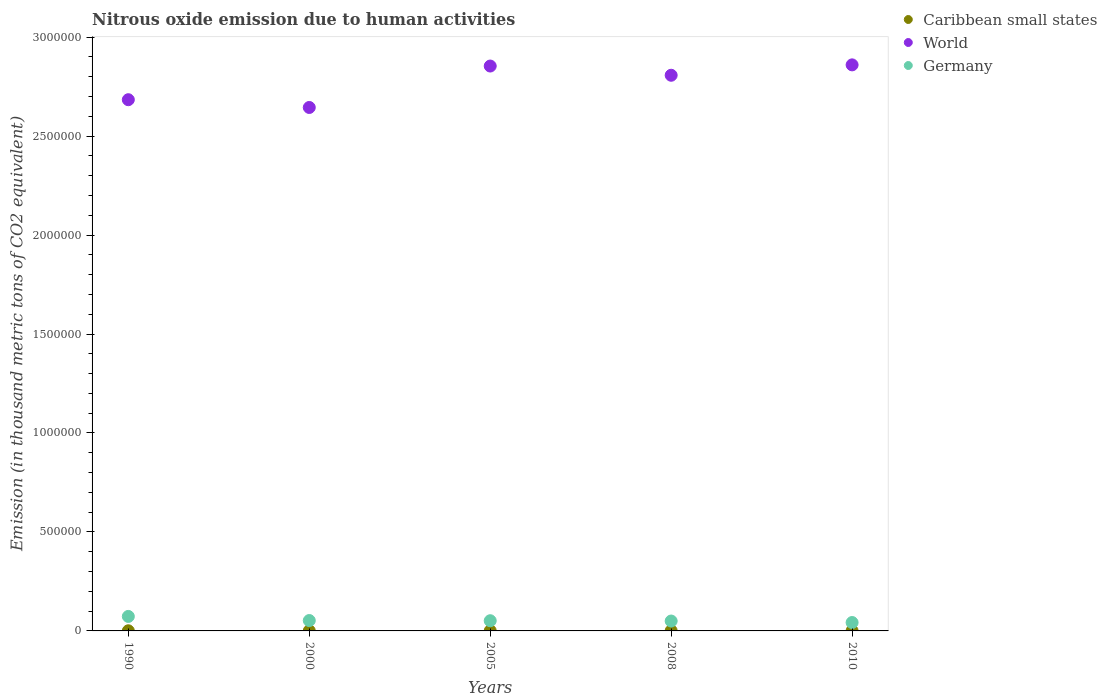What is the amount of nitrous oxide emitted in Caribbean small states in 2008?
Your answer should be compact. 1003.4. Across all years, what is the maximum amount of nitrous oxide emitted in Caribbean small states?
Keep it short and to the point. 1003.4. Across all years, what is the minimum amount of nitrous oxide emitted in Germany?
Make the answer very short. 4.24e+04. In which year was the amount of nitrous oxide emitted in Germany maximum?
Offer a terse response. 1990. In which year was the amount of nitrous oxide emitted in Caribbean small states minimum?
Offer a very short reply. 1990. What is the total amount of nitrous oxide emitted in Germany in the graph?
Make the answer very short. 2.70e+05. What is the difference between the amount of nitrous oxide emitted in Caribbean small states in 2008 and that in 2010?
Provide a short and direct response. 84.3. What is the difference between the amount of nitrous oxide emitted in Caribbean small states in 1990 and the amount of nitrous oxide emitted in World in 2005?
Provide a succinct answer. -2.85e+06. What is the average amount of nitrous oxide emitted in Caribbean small states per year?
Offer a very short reply. 882.52. In the year 2010, what is the difference between the amount of nitrous oxide emitted in Germany and amount of nitrous oxide emitted in Caribbean small states?
Ensure brevity in your answer.  4.15e+04. In how many years, is the amount of nitrous oxide emitted in World greater than 500000 thousand metric tons?
Your response must be concise. 5. What is the ratio of the amount of nitrous oxide emitted in Caribbean small states in 1990 to that in 2008?
Your answer should be very brief. 0.7. Is the difference between the amount of nitrous oxide emitted in Germany in 2008 and 2010 greater than the difference between the amount of nitrous oxide emitted in Caribbean small states in 2008 and 2010?
Offer a terse response. Yes. What is the difference between the highest and the second highest amount of nitrous oxide emitted in Germany?
Give a very brief answer. 2.07e+04. What is the difference between the highest and the lowest amount of nitrous oxide emitted in World?
Your response must be concise. 2.15e+05. Is it the case that in every year, the sum of the amount of nitrous oxide emitted in Caribbean small states and amount of nitrous oxide emitted in World  is greater than the amount of nitrous oxide emitted in Germany?
Keep it short and to the point. Yes. Does the amount of nitrous oxide emitted in World monotonically increase over the years?
Provide a short and direct response. No. Is the amount of nitrous oxide emitted in World strictly greater than the amount of nitrous oxide emitted in Caribbean small states over the years?
Make the answer very short. Yes. Is the amount of nitrous oxide emitted in World strictly less than the amount of nitrous oxide emitted in Caribbean small states over the years?
Offer a terse response. No. How many years are there in the graph?
Your answer should be compact. 5. What is the difference between two consecutive major ticks on the Y-axis?
Provide a succinct answer. 5.00e+05. Does the graph contain any zero values?
Provide a short and direct response. No. Where does the legend appear in the graph?
Offer a terse response. Top right. What is the title of the graph?
Provide a succinct answer. Nitrous oxide emission due to human activities. What is the label or title of the Y-axis?
Provide a short and direct response. Emission (in thousand metric tons of CO2 equivalent). What is the Emission (in thousand metric tons of CO2 equivalent) in Caribbean small states in 1990?
Give a very brief answer. 699.1. What is the Emission (in thousand metric tons of CO2 equivalent) in World in 1990?
Provide a succinct answer. 2.68e+06. What is the Emission (in thousand metric tons of CO2 equivalent) in Germany in 1990?
Your answer should be very brief. 7.32e+04. What is the Emission (in thousand metric tons of CO2 equivalent) of Caribbean small states in 2000?
Make the answer very short. 867.7. What is the Emission (in thousand metric tons of CO2 equivalent) in World in 2000?
Provide a succinct answer. 2.64e+06. What is the Emission (in thousand metric tons of CO2 equivalent) in Germany in 2000?
Your response must be concise. 5.25e+04. What is the Emission (in thousand metric tons of CO2 equivalent) in Caribbean small states in 2005?
Make the answer very short. 923.3. What is the Emission (in thousand metric tons of CO2 equivalent) of World in 2005?
Your answer should be very brief. 2.85e+06. What is the Emission (in thousand metric tons of CO2 equivalent) in Germany in 2005?
Provide a succinct answer. 5.15e+04. What is the Emission (in thousand metric tons of CO2 equivalent) of Caribbean small states in 2008?
Your answer should be compact. 1003.4. What is the Emission (in thousand metric tons of CO2 equivalent) in World in 2008?
Make the answer very short. 2.81e+06. What is the Emission (in thousand metric tons of CO2 equivalent) of Germany in 2008?
Ensure brevity in your answer.  5.00e+04. What is the Emission (in thousand metric tons of CO2 equivalent) of Caribbean small states in 2010?
Provide a short and direct response. 919.1. What is the Emission (in thousand metric tons of CO2 equivalent) in World in 2010?
Your answer should be very brief. 2.86e+06. What is the Emission (in thousand metric tons of CO2 equivalent) in Germany in 2010?
Give a very brief answer. 4.24e+04. Across all years, what is the maximum Emission (in thousand metric tons of CO2 equivalent) in Caribbean small states?
Your answer should be very brief. 1003.4. Across all years, what is the maximum Emission (in thousand metric tons of CO2 equivalent) of World?
Offer a very short reply. 2.86e+06. Across all years, what is the maximum Emission (in thousand metric tons of CO2 equivalent) in Germany?
Offer a very short reply. 7.32e+04. Across all years, what is the minimum Emission (in thousand metric tons of CO2 equivalent) in Caribbean small states?
Your answer should be compact. 699.1. Across all years, what is the minimum Emission (in thousand metric tons of CO2 equivalent) of World?
Give a very brief answer. 2.64e+06. Across all years, what is the minimum Emission (in thousand metric tons of CO2 equivalent) in Germany?
Your answer should be very brief. 4.24e+04. What is the total Emission (in thousand metric tons of CO2 equivalent) of Caribbean small states in the graph?
Provide a succinct answer. 4412.6. What is the total Emission (in thousand metric tons of CO2 equivalent) in World in the graph?
Your answer should be compact. 1.38e+07. What is the total Emission (in thousand metric tons of CO2 equivalent) in Germany in the graph?
Offer a terse response. 2.70e+05. What is the difference between the Emission (in thousand metric tons of CO2 equivalent) in Caribbean small states in 1990 and that in 2000?
Give a very brief answer. -168.6. What is the difference between the Emission (in thousand metric tons of CO2 equivalent) of World in 1990 and that in 2000?
Your response must be concise. 3.92e+04. What is the difference between the Emission (in thousand metric tons of CO2 equivalent) of Germany in 1990 and that in 2000?
Your response must be concise. 2.07e+04. What is the difference between the Emission (in thousand metric tons of CO2 equivalent) in Caribbean small states in 1990 and that in 2005?
Provide a short and direct response. -224.2. What is the difference between the Emission (in thousand metric tons of CO2 equivalent) of World in 1990 and that in 2005?
Your answer should be compact. -1.70e+05. What is the difference between the Emission (in thousand metric tons of CO2 equivalent) of Germany in 1990 and that in 2005?
Ensure brevity in your answer.  2.17e+04. What is the difference between the Emission (in thousand metric tons of CO2 equivalent) in Caribbean small states in 1990 and that in 2008?
Provide a succinct answer. -304.3. What is the difference between the Emission (in thousand metric tons of CO2 equivalent) in World in 1990 and that in 2008?
Provide a succinct answer. -1.24e+05. What is the difference between the Emission (in thousand metric tons of CO2 equivalent) of Germany in 1990 and that in 2008?
Ensure brevity in your answer.  2.32e+04. What is the difference between the Emission (in thousand metric tons of CO2 equivalent) of Caribbean small states in 1990 and that in 2010?
Provide a succinct answer. -220. What is the difference between the Emission (in thousand metric tons of CO2 equivalent) of World in 1990 and that in 2010?
Provide a succinct answer. -1.76e+05. What is the difference between the Emission (in thousand metric tons of CO2 equivalent) of Germany in 1990 and that in 2010?
Offer a terse response. 3.08e+04. What is the difference between the Emission (in thousand metric tons of CO2 equivalent) of Caribbean small states in 2000 and that in 2005?
Provide a succinct answer. -55.6. What is the difference between the Emission (in thousand metric tons of CO2 equivalent) in World in 2000 and that in 2005?
Give a very brief answer. -2.09e+05. What is the difference between the Emission (in thousand metric tons of CO2 equivalent) in Germany in 2000 and that in 2005?
Provide a short and direct response. 945.2. What is the difference between the Emission (in thousand metric tons of CO2 equivalent) of Caribbean small states in 2000 and that in 2008?
Offer a very short reply. -135.7. What is the difference between the Emission (in thousand metric tons of CO2 equivalent) in World in 2000 and that in 2008?
Offer a very short reply. -1.63e+05. What is the difference between the Emission (in thousand metric tons of CO2 equivalent) in Germany in 2000 and that in 2008?
Provide a succinct answer. 2493.2. What is the difference between the Emission (in thousand metric tons of CO2 equivalent) in Caribbean small states in 2000 and that in 2010?
Give a very brief answer. -51.4. What is the difference between the Emission (in thousand metric tons of CO2 equivalent) of World in 2000 and that in 2010?
Make the answer very short. -2.15e+05. What is the difference between the Emission (in thousand metric tons of CO2 equivalent) in Germany in 2000 and that in 2010?
Offer a terse response. 1.00e+04. What is the difference between the Emission (in thousand metric tons of CO2 equivalent) of Caribbean small states in 2005 and that in 2008?
Make the answer very short. -80.1. What is the difference between the Emission (in thousand metric tons of CO2 equivalent) in World in 2005 and that in 2008?
Offer a very short reply. 4.66e+04. What is the difference between the Emission (in thousand metric tons of CO2 equivalent) of Germany in 2005 and that in 2008?
Offer a terse response. 1548. What is the difference between the Emission (in thousand metric tons of CO2 equivalent) in World in 2005 and that in 2010?
Offer a terse response. -5911.5. What is the difference between the Emission (in thousand metric tons of CO2 equivalent) of Germany in 2005 and that in 2010?
Provide a short and direct response. 9081.9. What is the difference between the Emission (in thousand metric tons of CO2 equivalent) of Caribbean small states in 2008 and that in 2010?
Your answer should be very brief. 84.3. What is the difference between the Emission (in thousand metric tons of CO2 equivalent) in World in 2008 and that in 2010?
Ensure brevity in your answer.  -5.25e+04. What is the difference between the Emission (in thousand metric tons of CO2 equivalent) of Germany in 2008 and that in 2010?
Make the answer very short. 7533.9. What is the difference between the Emission (in thousand metric tons of CO2 equivalent) of Caribbean small states in 1990 and the Emission (in thousand metric tons of CO2 equivalent) of World in 2000?
Your response must be concise. -2.64e+06. What is the difference between the Emission (in thousand metric tons of CO2 equivalent) in Caribbean small states in 1990 and the Emission (in thousand metric tons of CO2 equivalent) in Germany in 2000?
Provide a succinct answer. -5.18e+04. What is the difference between the Emission (in thousand metric tons of CO2 equivalent) in World in 1990 and the Emission (in thousand metric tons of CO2 equivalent) in Germany in 2000?
Give a very brief answer. 2.63e+06. What is the difference between the Emission (in thousand metric tons of CO2 equivalent) of Caribbean small states in 1990 and the Emission (in thousand metric tons of CO2 equivalent) of World in 2005?
Ensure brevity in your answer.  -2.85e+06. What is the difference between the Emission (in thousand metric tons of CO2 equivalent) of Caribbean small states in 1990 and the Emission (in thousand metric tons of CO2 equivalent) of Germany in 2005?
Provide a succinct answer. -5.08e+04. What is the difference between the Emission (in thousand metric tons of CO2 equivalent) of World in 1990 and the Emission (in thousand metric tons of CO2 equivalent) of Germany in 2005?
Your response must be concise. 2.63e+06. What is the difference between the Emission (in thousand metric tons of CO2 equivalent) of Caribbean small states in 1990 and the Emission (in thousand metric tons of CO2 equivalent) of World in 2008?
Ensure brevity in your answer.  -2.81e+06. What is the difference between the Emission (in thousand metric tons of CO2 equivalent) in Caribbean small states in 1990 and the Emission (in thousand metric tons of CO2 equivalent) in Germany in 2008?
Offer a terse response. -4.93e+04. What is the difference between the Emission (in thousand metric tons of CO2 equivalent) in World in 1990 and the Emission (in thousand metric tons of CO2 equivalent) in Germany in 2008?
Make the answer very short. 2.63e+06. What is the difference between the Emission (in thousand metric tons of CO2 equivalent) of Caribbean small states in 1990 and the Emission (in thousand metric tons of CO2 equivalent) of World in 2010?
Provide a succinct answer. -2.86e+06. What is the difference between the Emission (in thousand metric tons of CO2 equivalent) in Caribbean small states in 1990 and the Emission (in thousand metric tons of CO2 equivalent) in Germany in 2010?
Provide a succinct answer. -4.17e+04. What is the difference between the Emission (in thousand metric tons of CO2 equivalent) in World in 1990 and the Emission (in thousand metric tons of CO2 equivalent) in Germany in 2010?
Offer a very short reply. 2.64e+06. What is the difference between the Emission (in thousand metric tons of CO2 equivalent) of Caribbean small states in 2000 and the Emission (in thousand metric tons of CO2 equivalent) of World in 2005?
Keep it short and to the point. -2.85e+06. What is the difference between the Emission (in thousand metric tons of CO2 equivalent) of Caribbean small states in 2000 and the Emission (in thousand metric tons of CO2 equivalent) of Germany in 2005?
Offer a very short reply. -5.06e+04. What is the difference between the Emission (in thousand metric tons of CO2 equivalent) in World in 2000 and the Emission (in thousand metric tons of CO2 equivalent) in Germany in 2005?
Provide a short and direct response. 2.59e+06. What is the difference between the Emission (in thousand metric tons of CO2 equivalent) of Caribbean small states in 2000 and the Emission (in thousand metric tons of CO2 equivalent) of World in 2008?
Your answer should be compact. -2.81e+06. What is the difference between the Emission (in thousand metric tons of CO2 equivalent) of Caribbean small states in 2000 and the Emission (in thousand metric tons of CO2 equivalent) of Germany in 2008?
Provide a short and direct response. -4.91e+04. What is the difference between the Emission (in thousand metric tons of CO2 equivalent) in World in 2000 and the Emission (in thousand metric tons of CO2 equivalent) in Germany in 2008?
Offer a terse response. 2.59e+06. What is the difference between the Emission (in thousand metric tons of CO2 equivalent) of Caribbean small states in 2000 and the Emission (in thousand metric tons of CO2 equivalent) of World in 2010?
Give a very brief answer. -2.86e+06. What is the difference between the Emission (in thousand metric tons of CO2 equivalent) of Caribbean small states in 2000 and the Emission (in thousand metric tons of CO2 equivalent) of Germany in 2010?
Keep it short and to the point. -4.16e+04. What is the difference between the Emission (in thousand metric tons of CO2 equivalent) of World in 2000 and the Emission (in thousand metric tons of CO2 equivalent) of Germany in 2010?
Ensure brevity in your answer.  2.60e+06. What is the difference between the Emission (in thousand metric tons of CO2 equivalent) of Caribbean small states in 2005 and the Emission (in thousand metric tons of CO2 equivalent) of World in 2008?
Your answer should be compact. -2.81e+06. What is the difference between the Emission (in thousand metric tons of CO2 equivalent) in Caribbean small states in 2005 and the Emission (in thousand metric tons of CO2 equivalent) in Germany in 2008?
Ensure brevity in your answer.  -4.90e+04. What is the difference between the Emission (in thousand metric tons of CO2 equivalent) of World in 2005 and the Emission (in thousand metric tons of CO2 equivalent) of Germany in 2008?
Your answer should be compact. 2.80e+06. What is the difference between the Emission (in thousand metric tons of CO2 equivalent) of Caribbean small states in 2005 and the Emission (in thousand metric tons of CO2 equivalent) of World in 2010?
Provide a short and direct response. -2.86e+06. What is the difference between the Emission (in thousand metric tons of CO2 equivalent) of Caribbean small states in 2005 and the Emission (in thousand metric tons of CO2 equivalent) of Germany in 2010?
Make the answer very short. -4.15e+04. What is the difference between the Emission (in thousand metric tons of CO2 equivalent) of World in 2005 and the Emission (in thousand metric tons of CO2 equivalent) of Germany in 2010?
Keep it short and to the point. 2.81e+06. What is the difference between the Emission (in thousand metric tons of CO2 equivalent) of Caribbean small states in 2008 and the Emission (in thousand metric tons of CO2 equivalent) of World in 2010?
Give a very brief answer. -2.86e+06. What is the difference between the Emission (in thousand metric tons of CO2 equivalent) in Caribbean small states in 2008 and the Emission (in thousand metric tons of CO2 equivalent) in Germany in 2010?
Offer a terse response. -4.14e+04. What is the difference between the Emission (in thousand metric tons of CO2 equivalent) in World in 2008 and the Emission (in thousand metric tons of CO2 equivalent) in Germany in 2010?
Provide a short and direct response. 2.76e+06. What is the average Emission (in thousand metric tons of CO2 equivalent) in Caribbean small states per year?
Provide a short and direct response. 882.52. What is the average Emission (in thousand metric tons of CO2 equivalent) of World per year?
Your answer should be compact. 2.77e+06. What is the average Emission (in thousand metric tons of CO2 equivalent) in Germany per year?
Provide a short and direct response. 5.39e+04. In the year 1990, what is the difference between the Emission (in thousand metric tons of CO2 equivalent) in Caribbean small states and Emission (in thousand metric tons of CO2 equivalent) in World?
Make the answer very short. -2.68e+06. In the year 1990, what is the difference between the Emission (in thousand metric tons of CO2 equivalent) in Caribbean small states and Emission (in thousand metric tons of CO2 equivalent) in Germany?
Provide a succinct answer. -7.25e+04. In the year 1990, what is the difference between the Emission (in thousand metric tons of CO2 equivalent) in World and Emission (in thousand metric tons of CO2 equivalent) in Germany?
Make the answer very short. 2.61e+06. In the year 2000, what is the difference between the Emission (in thousand metric tons of CO2 equivalent) of Caribbean small states and Emission (in thousand metric tons of CO2 equivalent) of World?
Ensure brevity in your answer.  -2.64e+06. In the year 2000, what is the difference between the Emission (in thousand metric tons of CO2 equivalent) in Caribbean small states and Emission (in thousand metric tons of CO2 equivalent) in Germany?
Provide a succinct answer. -5.16e+04. In the year 2000, what is the difference between the Emission (in thousand metric tons of CO2 equivalent) of World and Emission (in thousand metric tons of CO2 equivalent) of Germany?
Offer a very short reply. 2.59e+06. In the year 2005, what is the difference between the Emission (in thousand metric tons of CO2 equivalent) in Caribbean small states and Emission (in thousand metric tons of CO2 equivalent) in World?
Offer a very short reply. -2.85e+06. In the year 2005, what is the difference between the Emission (in thousand metric tons of CO2 equivalent) of Caribbean small states and Emission (in thousand metric tons of CO2 equivalent) of Germany?
Give a very brief answer. -5.06e+04. In the year 2005, what is the difference between the Emission (in thousand metric tons of CO2 equivalent) of World and Emission (in thousand metric tons of CO2 equivalent) of Germany?
Your answer should be compact. 2.80e+06. In the year 2008, what is the difference between the Emission (in thousand metric tons of CO2 equivalent) in Caribbean small states and Emission (in thousand metric tons of CO2 equivalent) in World?
Ensure brevity in your answer.  -2.81e+06. In the year 2008, what is the difference between the Emission (in thousand metric tons of CO2 equivalent) in Caribbean small states and Emission (in thousand metric tons of CO2 equivalent) in Germany?
Offer a very short reply. -4.90e+04. In the year 2008, what is the difference between the Emission (in thousand metric tons of CO2 equivalent) of World and Emission (in thousand metric tons of CO2 equivalent) of Germany?
Offer a very short reply. 2.76e+06. In the year 2010, what is the difference between the Emission (in thousand metric tons of CO2 equivalent) in Caribbean small states and Emission (in thousand metric tons of CO2 equivalent) in World?
Make the answer very short. -2.86e+06. In the year 2010, what is the difference between the Emission (in thousand metric tons of CO2 equivalent) of Caribbean small states and Emission (in thousand metric tons of CO2 equivalent) of Germany?
Keep it short and to the point. -4.15e+04. In the year 2010, what is the difference between the Emission (in thousand metric tons of CO2 equivalent) in World and Emission (in thousand metric tons of CO2 equivalent) in Germany?
Make the answer very short. 2.82e+06. What is the ratio of the Emission (in thousand metric tons of CO2 equivalent) of Caribbean small states in 1990 to that in 2000?
Make the answer very short. 0.81. What is the ratio of the Emission (in thousand metric tons of CO2 equivalent) of World in 1990 to that in 2000?
Your answer should be compact. 1.01. What is the ratio of the Emission (in thousand metric tons of CO2 equivalent) of Germany in 1990 to that in 2000?
Your answer should be very brief. 1.4. What is the ratio of the Emission (in thousand metric tons of CO2 equivalent) in Caribbean small states in 1990 to that in 2005?
Provide a short and direct response. 0.76. What is the ratio of the Emission (in thousand metric tons of CO2 equivalent) of World in 1990 to that in 2005?
Your answer should be very brief. 0.94. What is the ratio of the Emission (in thousand metric tons of CO2 equivalent) in Germany in 1990 to that in 2005?
Your response must be concise. 1.42. What is the ratio of the Emission (in thousand metric tons of CO2 equivalent) of Caribbean small states in 1990 to that in 2008?
Ensure brevity in your answer.  0.7. What is the ratio of the Emission (in thousand metric tons of CO2 equivalent) of World in 1990 to that in 2008?
Your answer should be very brief. 0.96. What is the ratio of the Emission (in thousand metric tons of CO2 equivalent) in Germany in 1990 to that in 2008?
Offer a terse response. 1.46. What is the ratio of the Emission (in thousand metric tons of CO2 equivalent) of Caribbean small states in 1990 to that in 2010?
Offer a terse response. 0.76. What is the ratio of the Emission (in thousand metric tons of CO2 equivalent) of World in 1990 to that in 2010?
Make the answer very short. 0.94. What is the ratio of the Emission (in thousand metric tons of CO2 equivalent) in Germany in 1990 to that in 2010?
Provide a short and direct response. 1.72. What is the ratio of the Emission (in thousand metric tons of CO2 equivalent) in Caribbean small states in 2000 to that in 2005?
Keep it short and to the point. 0.94. What is the ratio of the Emission (in thousand metric tons of CO2 equivalent) of World in 2000 to that in 2005?
Your answer should be very brief. 0.93. What is the ratio of the Emission (in thousand metric tons of CO2 equivalent) of Germany in 2000 to that in 2005?
Give a very brief answer. 1.02. What is the ratio of the Emission (in thousand metric tons of CO2 equivalent) in Caribbean small states in 2000 to that in 2008?
Offer a very short reply. 0.86. What is the ratio of the Emission (in thousand metric tons of CO2 equivalent) in World in 2000 to that in 2008?
Your response must be concise. 0.94. What is the ratio of the Emission (in thousand metric tons of CO2 equivalent) of Germany in 2000 to that in 2008?
Provide a short and direct response. 1.05. What is the ratio of the Emission (in thousand metric tons of CO2 equivalent) in Caribbean small states in 2000 to that in 2010?
Provide a short and direct response. 0.94. What is the ratio of the Emission (in thousand metric tons of CO2 equivalent) in World in 2000 to that in 2010?
Provide a succinct answer. 0.92. What is the ratio of the Emission (in thousand metric tons of CO2 equivalent) of Germany in 2000 to that in 2010?
Provide a short and direct response. 1.24. What is the ratio of the Emission (in thousand metric tons of CO2 equivalent) of Caribbean small states in 2005 to that in 2008?
Provide a succinct answer. 0.92. What is the ratio of the Emission (in thousand metric tons of CO2 equivalent) in World in 2005 to that in 2008?
Your answer should be compact. 1.02. What is the ratio of the Emission (in thousand metric tons of CO2 equivalent) in Germany in 2005 to that in 2008?
Provide a succinct answer. 1.03. What is the ratio of the Emission (in thousand metric tons of CO2 equivalent) in Caribbean small states in 2005 to that in 2010?
Offer a very short reply. 1. What is the ratio of the Emission (in thousand metric tons of CO2 equivalent) of Germany in 2005 to that in 2010?
Keep it short and to the point. 1.21. What is the ratio of the Emission (in thousand metric tons of CO2 equivalent) of Caribbean small states in 2008 to that in 2010?
Your answer should be compact. 1.09. What is the ratio of the Emission (in thousand metric tons of CO2 equivalent) of World in 2008 to that in 2010?
Make the answer very short. 0.98. What is the ratio of the Emission (in thousand metric tons of CO2 equivalent) of Germany in 2008 to that in 2010?
Give a very brief answer. 1.18. What is the difference between the highest and the second highest Emission (in thousand metric tons of CO2 equivalent) in Caribbean small states?
Your answer should be compact. 80.1. What is the difference between the highest and the second highest Emission (in thousand metric tons of CO2 equivalent) of World?
Provide a succinct answer. 5911.5. What is the difference between the highest and the second highest Emission (in thousand metric tons of CO2 equivalent) of Germany?
Provide a short and direct response. 2.07e+04. What is the difference between the highest and the lowest Emission (in thousand metric tons of CO2 equivalent) in Caribbean small states?
Provide a short and direct response. 304.3. What is the difference between the highest and the lowest Emission (in thousand metric tons of CO2 equivalent) in World?
Keep it short and to the point. 2.15e+05. What is the difference between the highest and the lowest Emission (in thousand metric tons of CO2 equivalent) in Germany?
Make the answer very short. 3.08e+04. 